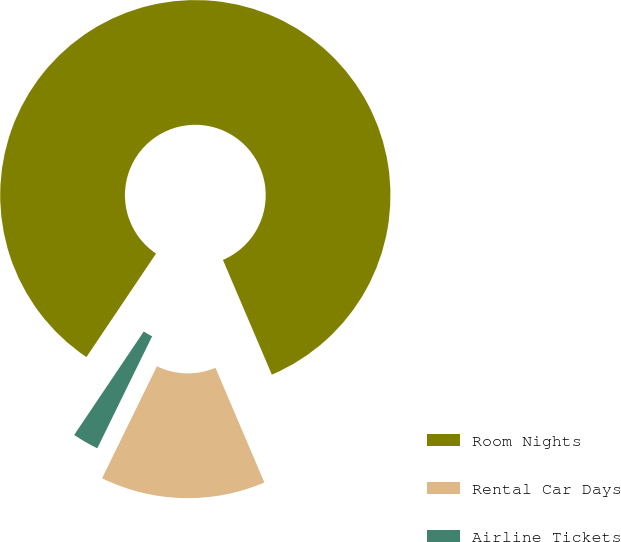Convert chart to OTSL. <chart><loc_0><loc_0><loc_500><loc_500><pie_chart><fcel>Room Nights<fcel>Rental Car Days<fcel>Airline Tickets<nl><fcel>84.16%<fcel>13.66%<fcel>2.18%<nl></chart> 